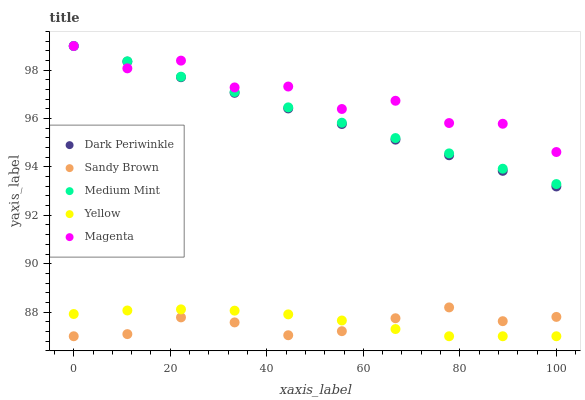Does Sandy Brown have the minimum area under the curve?
Answer yes or no. Yes. Does Magenta have the maximum area under the curve?
Answer yes or no. Yes. Does Magenta have the minimum area under the curve?
Answer yes or no. No. Does Sandy Brown have the maximum area under the curve?
Answer yes or no. No. Is Medium Mint the smoothest?
Answer yes or no. Yes. Is Magenta the roughest?
Answer yes or no. Yes. Is Sandy Brown the smoothest?
Answer yes or no. No. Is Sandy Brown the roughest?
Answer yes or no. No. Does Sandy Brown have the lowest value?
Answer yes or no. Yes. Does Magenta have the lowest value?
Answer yes or no. No. Does Dark Periwinkle have the highest value?
Answer yes or no. Yes. Does Sandy Brown have the highest value?
Answer yes or no. No. Is Sandy Brown less than Dark Periwinkle?
Answer yes or no. Yes. Is Magenta greater than Sandy Brown?
Answer yes or no. Yes. Does Medium Mint intersect Magenta?
Answer yes or no. Yes. Is Medium Mint less than Magenta?
Answer yes or no. No. Is Medium Mint greater than Magenta?
Answer yes or no. No. Does Sandy Brown intersect Dark Periwinkle?
Answer yes or no. No. 